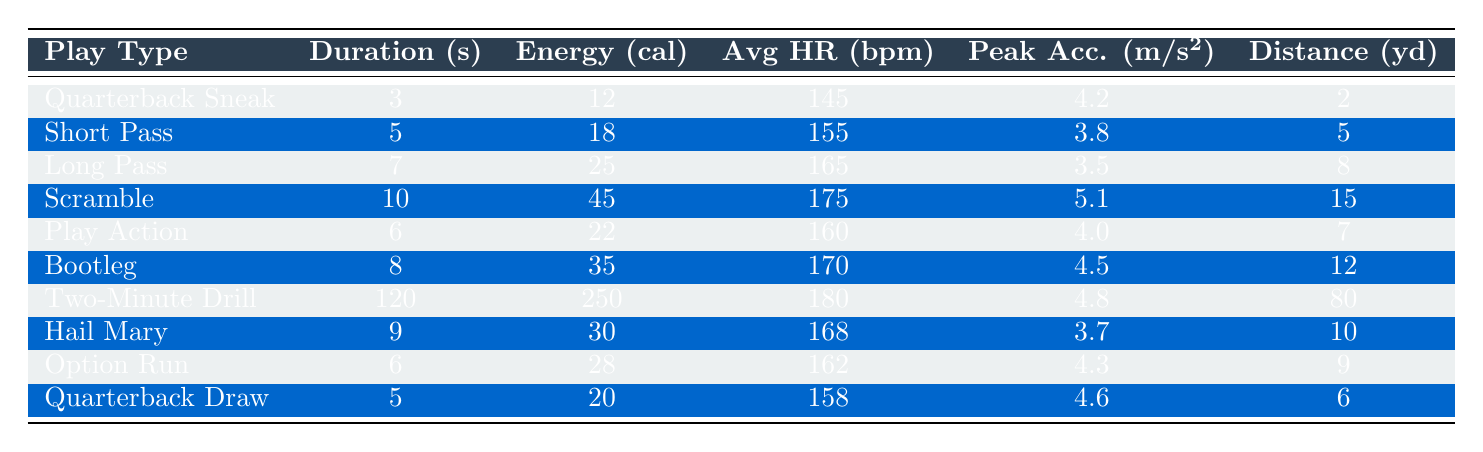What is the energy expenditure of a quarterback during a scramble? The table shows that for the "Scramble" play type, the energy expenditure is listed as 45 calories.
Answer: 45 calories Which play has the longest duration? By comparing the durations of all play types, "Two-Minute Drill" has the greatest duration at 120 seconds.
Answer: 120 seconds Is the average heart rate during a quarterback sneak higher than during a short pass? The average heart rate for "Quarterback Sneak" is 145 bpm, while for "Short Pass" it is 155 bpm. Since 145 is less than 155, the statement is false.
Answer: No What is the total energy expenditure for the three highest energy plays? The three highest energy expenditures are: Scramble (45), Bootleg (35), and Two-Minute Drill (250). Adding these gives 45 + 35 + 250 = 330 calories.
Answer: 330 calories Which play types have an average heart rate greater than 170 bpm? The only play type with an average heart rate greater than 170 bpm is "Scramble" (175 bpm) and "Two-Minute Drill" (180 bpm). Therefore, two play types meet this criterion.
Answer: 2 What is the average energy expenditure across all plays? To find the average: sum the energy expenditures (12 + 18 + 25 + 45 + 22 + 35 + 250 + 30 + 28 + 20) =  2 + 12 + 18 + 22 + 25 + 28 + 30 + 35 + 45 + 250 =  459 calories. There are 10 play types, so the average is 459/10 = 45.9 calories.
Answer: 45.9 calories Which play covers the least distance? "Quarterback Sneak" covers the least distance at 2 yards compared to other plays listed in the table.
Answer: 2 yards What is the peak acceleration during the "Hail Mary" play? The peak acceleration for "Hail Mary" is listed as 3.7 m/s^2 in the table.
Answer: 3.7 m/s^2 Of the plays listed, which has the highest peak acceleration and what is it? The "Scramble" has the highest peak acceleration at 5.1 m/s^2, which can be identified by comparing the peak acceleration values for all plays.
Answer: 5.1 m/s^2 If the scramble play was played three times, how much energy would the quarterback expend? The energy expenditure for one scramble is 45 calories. Therefore, for three scrambles: 45 calories x 3 = 135 calories.
Answer: 135 calories How does the energy expenditure from a play action compare to a short pass? The energy expenditure for "Play Action" is 22 calories, while "Short Pass" is 18 calories. Since 22 is greater than 18, "Play Action" has higher energy expenditure.
Answer: Higher 